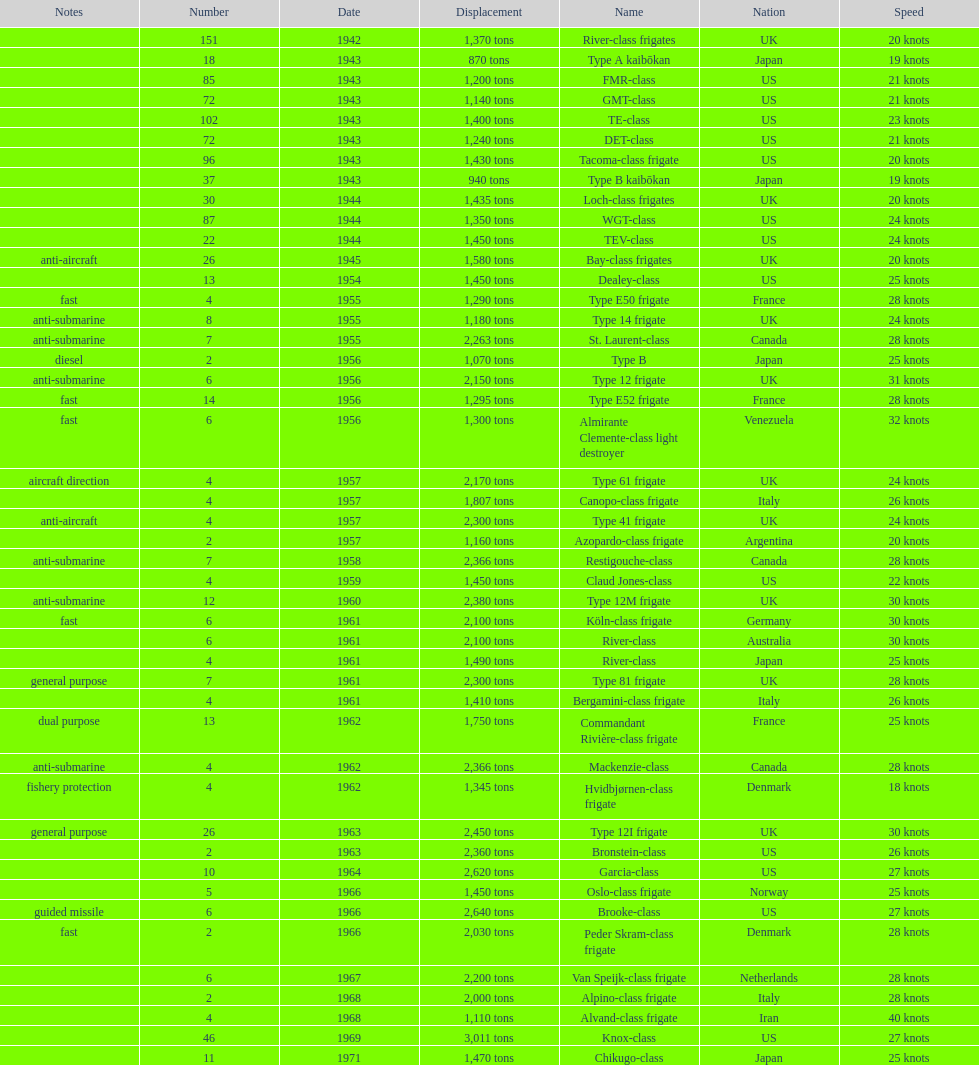Parse the table in full. {'header': ['Notes', 'Number', 'Date', 'Displacement', 'Name', 'Nation', 'Speed'], 'rows': [['', '151', '1942', '1,370 tons', 'River-class frigates', 'UK', '20 knots'], ['', '18', '1943', '870 tons', 'Type A kaibōkan', 'Japan', '19 knots'], ['', '85', '1943', '1,200 tons', 'FMR-class', 'US', '21 knots'], ['', '72', '1943', '1,140 tons', 'GMT-class', 'US', '21 knots'], ['', '102', '1943', '1,400 tons', 'TE-class', 'US', '23 knots'], ['', '72', '1943', '1,240 tons', 'DET-class', 'US', '21 knots'], ['', '96', '1943', '1,430 tons', 'Tacoma-class frigate', 'US', '20 knots'], ['', '37', '1943', '940 tons', 'Type B kaibōkan', 'Japan', '19 knots'], ['', '30', '1944', '1,435 tons', 'Loch-class frigates', 'UK', '20 knots'], ['', '87', '1944', '1,350 tons', 'WGT-class', 'US', '24 knots'], ['', '22', '1944', '1,450 tons', 'TEV-class', 'US', '24 knots'], ['anti-aircraft', '26', '1945', '1,580 tons', 'Bay-class frigates', 'UK', '20 knots'], ['', '13', '1954', '1,450 tons', 'Dealey-class', 'US', '25 knots'], ['fast', '4', '1955', '1,290 tons', 'Type E50 frigate', 'France', '28 knots'], ['anti-submarine', '8', '1955', '1,180 tons', 'Type 14 frigate', 'UK', '24 knots'], ['anti-submarine', '7', '1955', '2,263 tons', 'St. Laurent-class', 'Canada', '28 knots'], ['diesel', '2', '1956', '1,070 tons', 'Type B', 'Japan', '25 knots'], ['anti-submarine', '6', '1956', '2,150 tons', 'Type 12 frigate', 'UK', '31 knots'], ['fast', '14', '1956', '1,295 tons', 'Type E52 frigate', 'France', '28 knots'], ['fast', '6', '1956', '1,300 tons', 'Almirante Clemente-class light destroyer', 'Venezuela', '32 knots'], ['aircraft direction', '4', '1957', '2,170 tons', 'Type 61 frigate', 'UK', '24 knots'], ['', '4', '1957', '1,807 tons', 'Canopo-class frigate', 'Italy', '26 knots'], ['anti-aircraft', '4', '1957', '2,300 tons', 'Type 41 frigate', 'UK', '24 knots'], ['', '2', '1957', '1,160 tons', 'Azopardo-class frigate', 'Argentina', '20 knots'], ['anti-submarine', '7', '1958', '2,366 tons', 'Restigouche-class', 'Canada', '28 knots'], ['', '4', '1959', '1,450 tons', 'Claud Jones-class', 'US', '22 knots'], ['anti-submarine', '12', '1960', '2,380 tons', 'Type 12M frigate', 'UK', '30 knots'], ['fast', '6', '1961', '2,100 tons', 'Köln-class frigate', 'Germany', '30 knots'], ['', '6', '1961', '2,100 tons', 'River-class', 'Australia', '30 knots'], ['', '4', '1961', '1,490 tons', 'River-class', 'Japan', '25 knots'], ['general purpose', '7', '1961', '2,300 tons', 'Type 81 frigate', 'UK', '28 knots'], ['', '4', '1961', '1,410 tons', 'Bergamini-class frigate', 'Italy', '26 knots'], ['dual purpose', '13', '1962', '1,750 tons', 'Commandant Rivière-class frigate', 'France', '25 knots'], ['anti-submarine', '4', '1962', '2,366 tons', 'Mackenzie-class', 'Canada', '28 knots'], ['fishery protection', '4', '1962', '1,345 tons', 'Hvidbjørnen-class frigate', 'Denmark', '18 knots'], ['general purpose', '26', '1963', '2,450 tons', 'Type 12I frigate', 'UK', '30 knots'], ['', '2', '1963', '2,360 tons', 'Bronstein-class', 'US', '26 knots'], ['', '10', '1964', '2,620 tons', 'Garcia-class', 'US', '27 knots'], ['', '5', '1966', '1,450 tons', 'Oslo-class frigate', 'Norway', '25 knots'], ['guided missile', '6', '1966', '2,640 tons', 'Brooke-class', 'US', '27 knots'], ['fast', '2', '1966', '2,030 tons', 'Peder Skram-class frigate', 'Denmark', '28 knots'], ['', '6', '1967', '2,200 tons', 'Van Speijk-class frigate', 'Netherlands', '28 knots'], ['', '2', '1968', '2,000 tons', 'Alpino-class frigate', 'Italy', '28 knots'], ['', '4', '1968', '1,110 tons', 'Alvand-class frigate', 'Iran', '40 knots'], ['', '46', '1969', '3,011 tons', 'Knox-class', 'US', '27 knots'], ['', '11', '1971', '1,470 tons', 'Chikugo-class', 'Japan', '25 knots']]} How many consecutive escorts were in 1943? 7. 